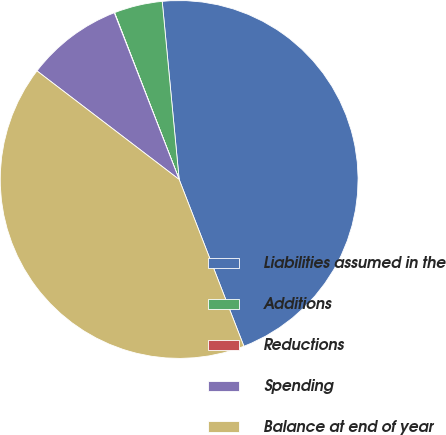Convert chart to OTSL. <chart><loc_0><loc_0><loc_500><loc_500><pie_chart><fcel>Liabilities assumed in the<fcel>Additions<fcel>Reductions<fcel>Spending<fcel>Balance at end of year<nl><fcel>45.61%<fcel>4.37%<fcel>0.03%<fcel>8.71%<fcel>41.27%<nl></chart> 